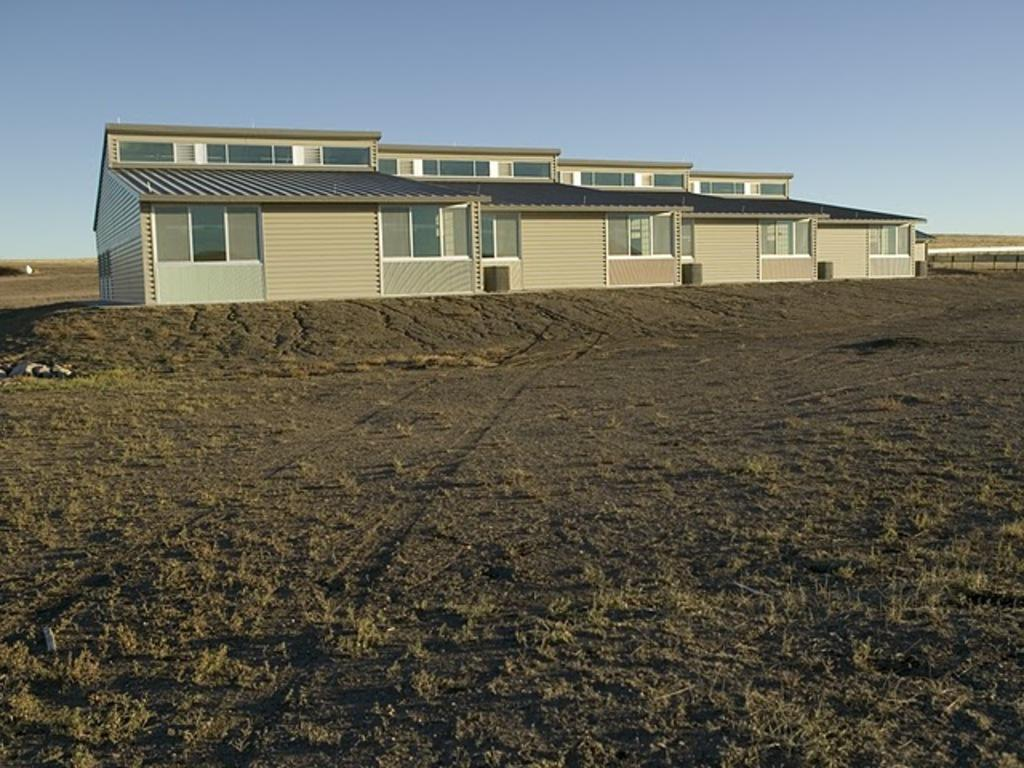What type of structures are present in the image? There are houses in the image. What feature can be seen on the houses? The houses have glass windows. What type of fence is located beside the houses? There is a metal rod mesh fence beside the houses. What type of scissors can be seen on the roof of the houses in the image? There are no scissors present on the roof of the houses in the image. 